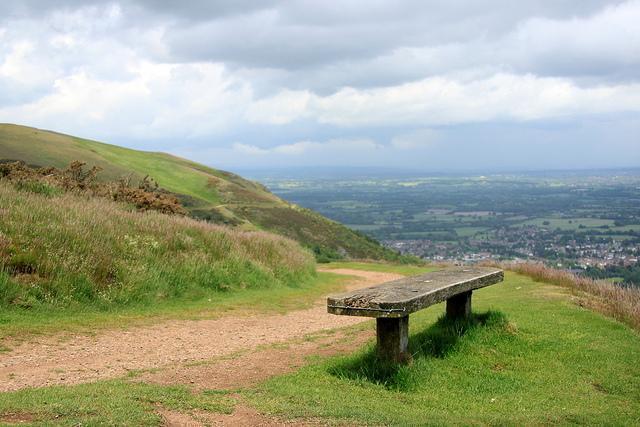How many people are sitting on the bench?
Give a very brief answer. 0. 